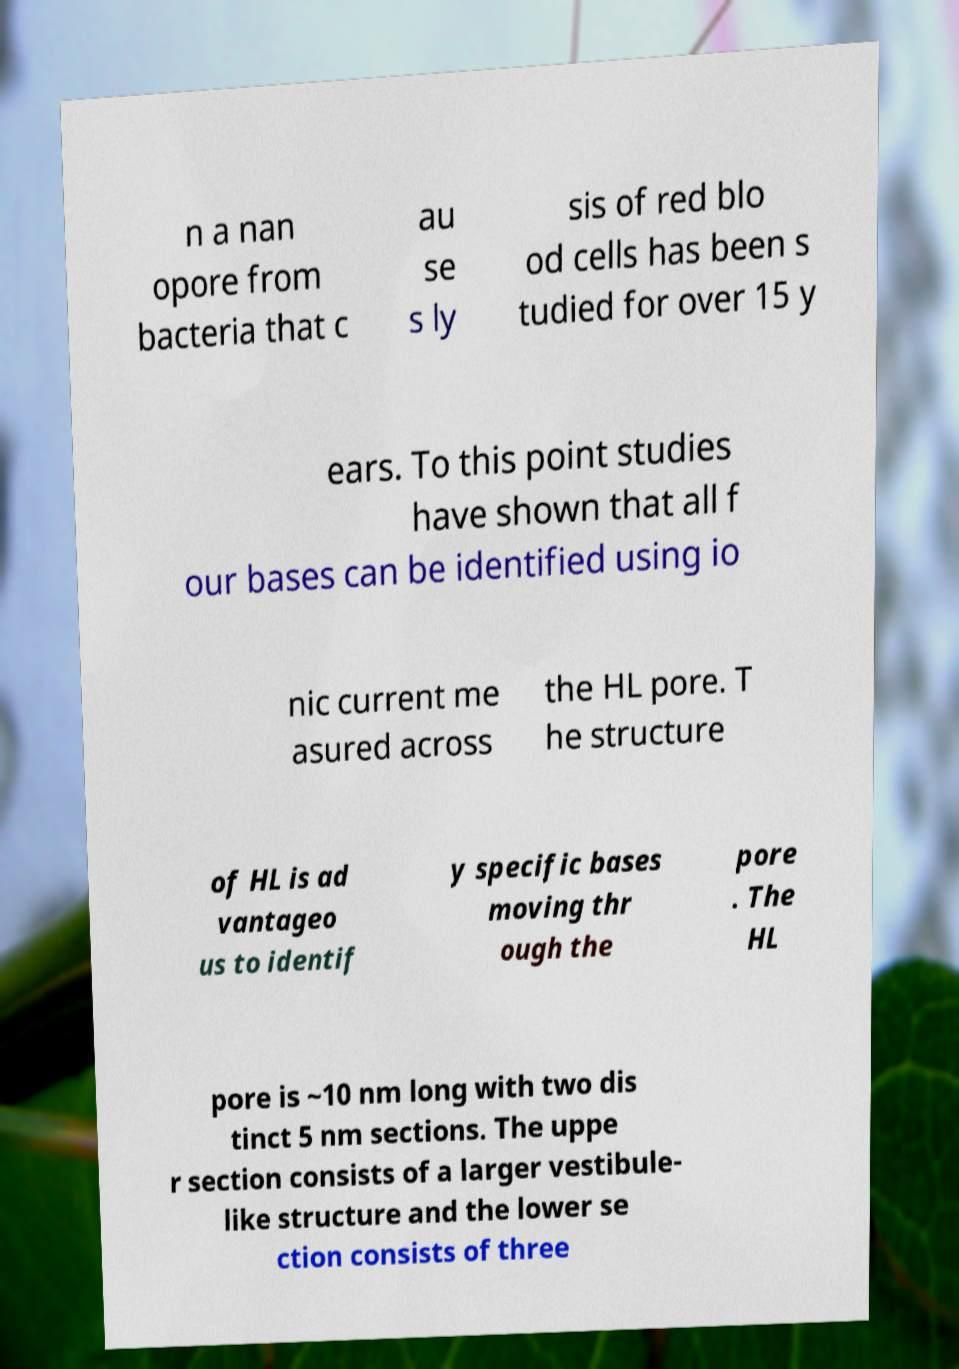What messages or text are displayed in this image? I need them in a readable, typed format. n a nan opore from bacteria that c au se s ly sis of red blo od cells has been s tudied for over 15 y ears. To this point studies have shown that all f our bases can be identified using io nic current me asured across the HL pore. T he structure of HL is ad vantageo us to identif y specific bases moving thr ough the pore . The HL pore is ~10 nm long with two dis tinct 5 nm sections. The uppe r section consists of a larger vestibule- like structure and the lower se ction consists of three 